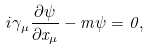<formula> <loc_0><loc_0><loc_500><loc_500>i \gamma _ { \mu } \frac { \partial \psi } { \partial x _ { \mu } } - m \psi = 0 ,</formula> 